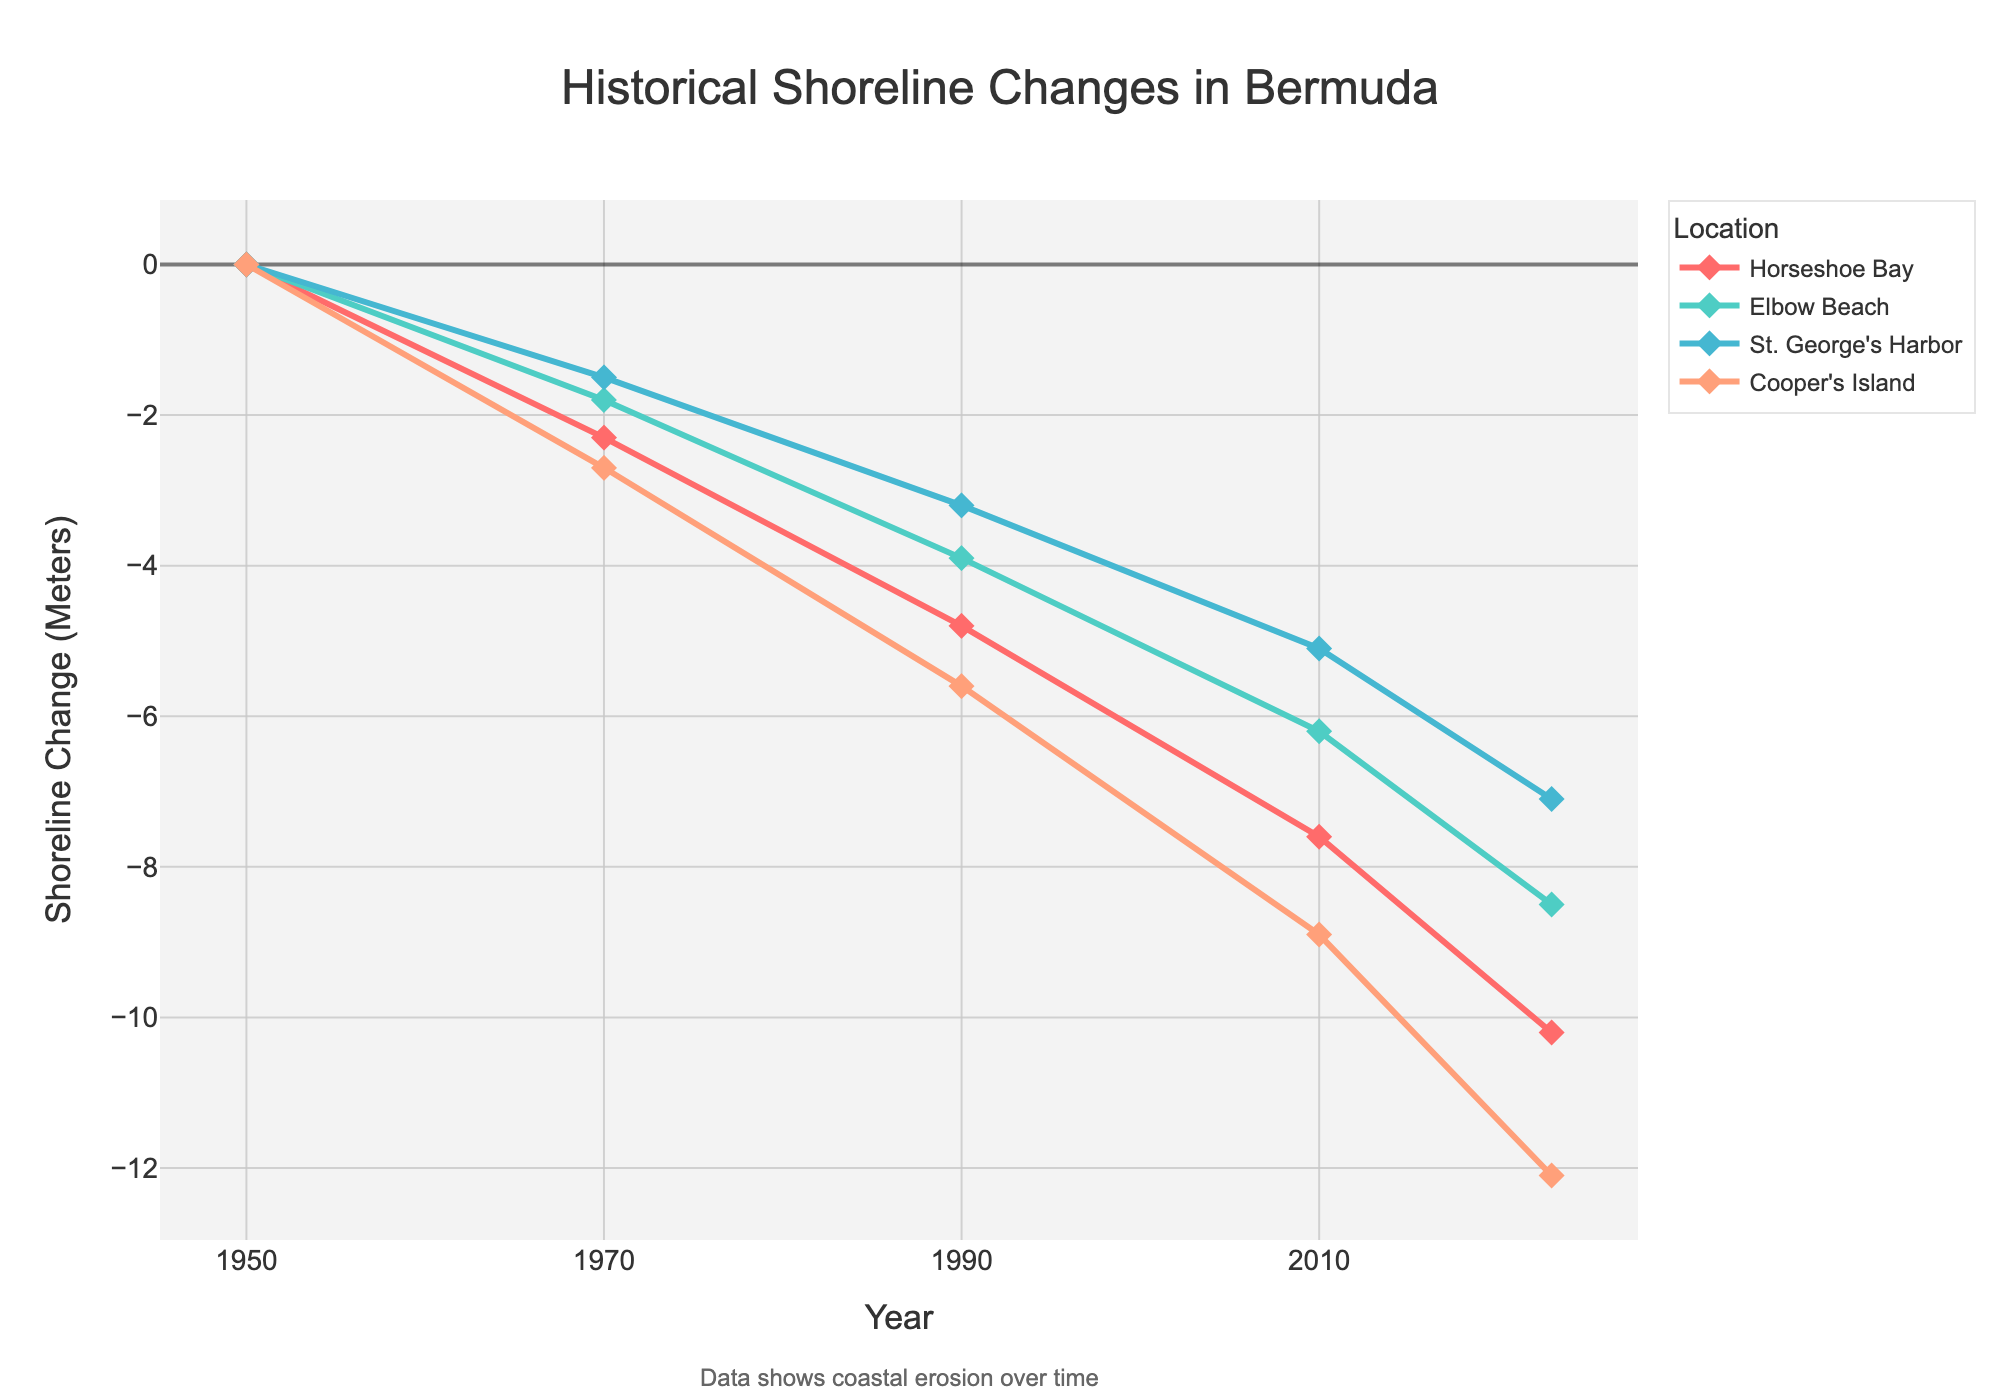What is the title of the plot? The title is located at the top center of the plot. It reads "Historical Shoreline Changes in Bermuda."
Answer: Historical Shoreline Changes in Bermuda Which location has experienced the most shoreline change by 2023? By looking at the data points for 2023 for each location, we see that Cooper's Island has the most negative shoreline change at -12.1 meters. This indicates the most significant erosion.
Answer: Cooper's Island What is the range of years depicted on the x-axis? The x-axis starts at 1950 and ends at 2023, indicating the range of years for the data presented.
Answer: 1950 to 2023 How many locations are shown in the plot? The legend lists all the locations, and there are four: Horseshoe Bay, Elbow Beach, St. George's Harbor, and Cooper's Island.
Answer: Four Which years show the steepest decline in shoreline for Horseshoe Bay? To determine the steepest decline, we need to look at the differences between consecutive data points for Horseshoe Bay. The steepest decline occurs between 1990 and 2010, from -4.8 meters to -7.6 meters, a difference of 2.8 meters.
Answer: 1990 to 2010 What is the combined shoreline change across all locations in 2023? Add up the 2023 values for all locations: -10.2 + -8.5 + -7.1 + -12.1 = -37.9 meters.
Answer: -37.9 meters How does Elbow Beach's future projection for 2050 compare to its 2023 value? Elbow Beach's 2023 value is -8.5 meters, and its 2050 projection is -19.3 meters. The difference is -19.3 - (-8.5) = -10.8 meters.
Answer: -10.8 meters Which location shows the most consistent shoreline change over the years? By examining the slopes of the lines for each location, Elbow Beach shows the most consistent, gradual shoreline change with smaller increments over time.
Answer: Elbow Beach How much more erosion is projected for Cooper's Island by 2050 compared to 2023? The 2023 value for Cooper's Island is -12.1 meters, and the 2050 projection is -27.2 meters. The projected additional erosion is -27.2 - (-12.1)= -15.1 meters.
Answer: -15.1 meters 